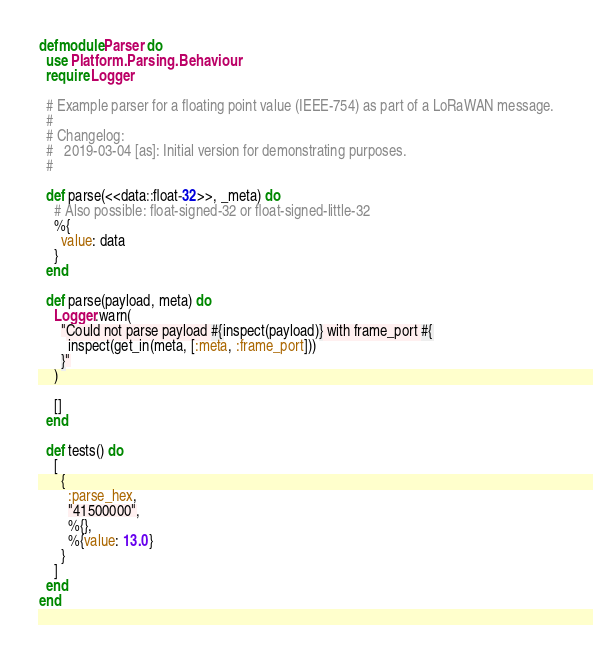<code> <loc_0><loc_0><loc_500><loc_500><_Elixir_>defmodule Parser do
  use Platform.Parsing.Behaviour
  require Logger

  # Example parser for a floating point value (IEEE-754) as part of a LoRaWAN message.
  #
  # Changelog:
  #   2019-03-04 [as]: Initial version for demonstrating purposes.
  #

  def parse(<<data::float-32>>, _meta) do
    # Also possible: float-signed-32 or float-signed-little-32
    %{
      value: data
    }
  end

  def parse(payload, meta) do
    Logger.warn(
      "Could not parse payload #{inspect(payload)} with frame_port #{
        inspect(get_in(meta, [:meta, :frame_port]))
      }"
    )

    []
  end

  def tests() do
    [
      {
        :parse_hex,
        "41500000",
        %{},
        %{value: 13.0}
      }
    ]
  end
end
</code> 